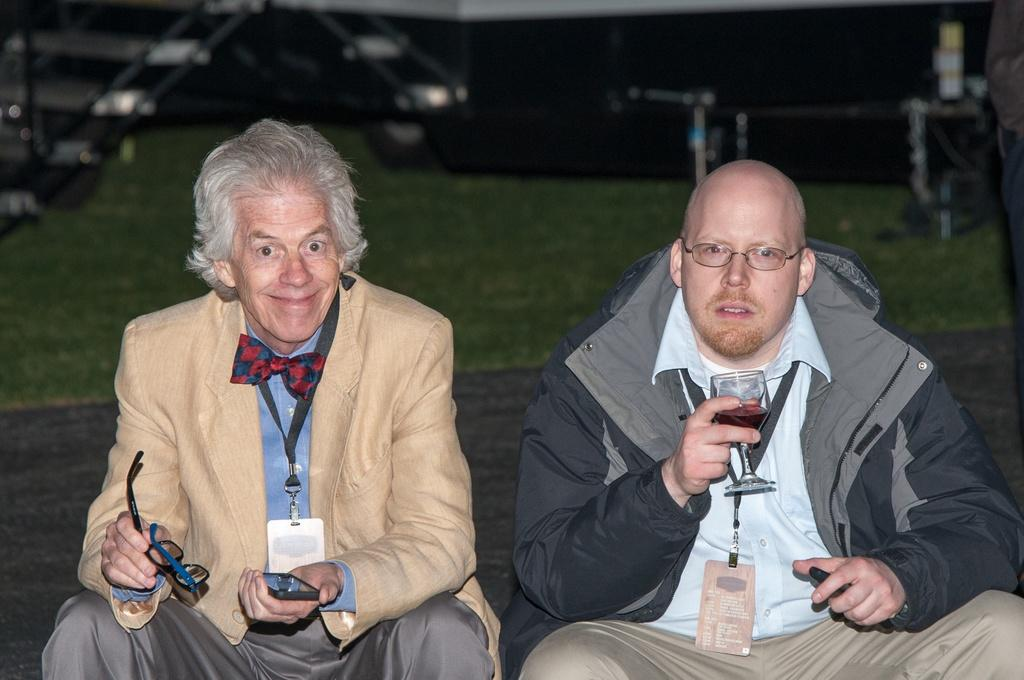How many men are in the image? There are two men in the image. What is the man wearing a black jacket holding? The man in the black jacket is holding a glass. What is the other man holding? The other man is holding spectacles and a phone. What type of surface can be seen in the image? There is grass visible in the image. What type of flower is growing in the committee meeting in the image? There is no committee meeting or flower present in the image. 